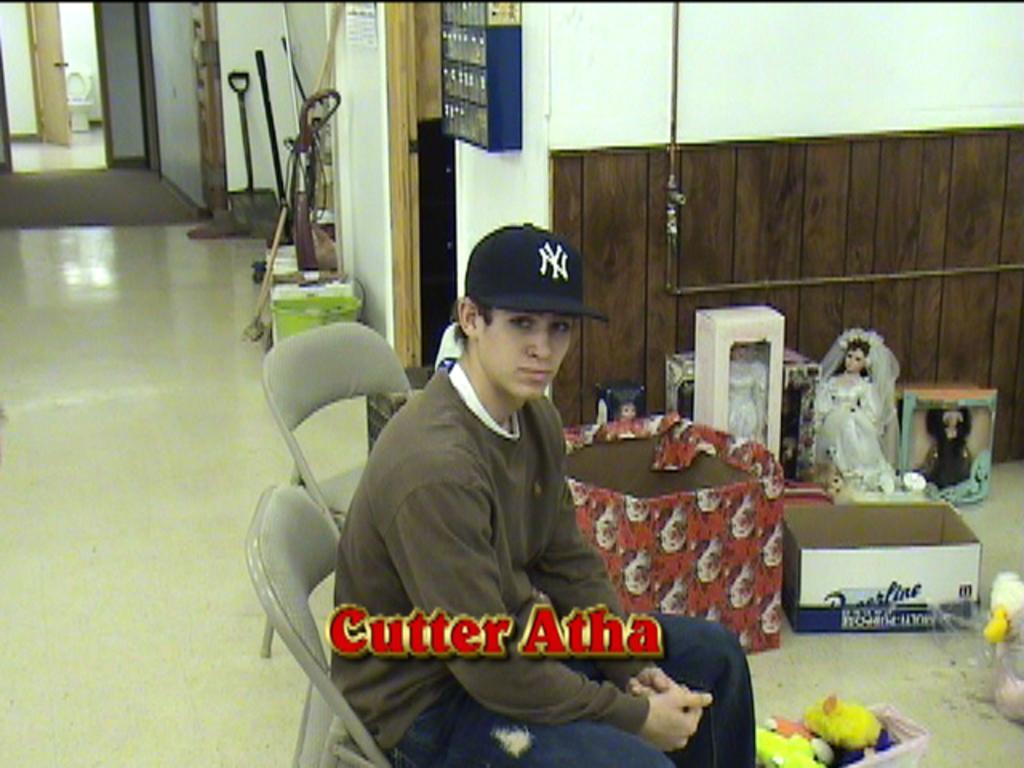Can you describe this image briefly? In this image I can see a man is sitting on a chair in the front. I can see he is wearing t shirt, jeans and a cap. On the right side of this image I can see few boxes, few dolls, few other toys and behind him I can see an empty chair. In the background I can see few tools and a blue colour thing on the wall. On the bottom side of this image I can see a watermark. 